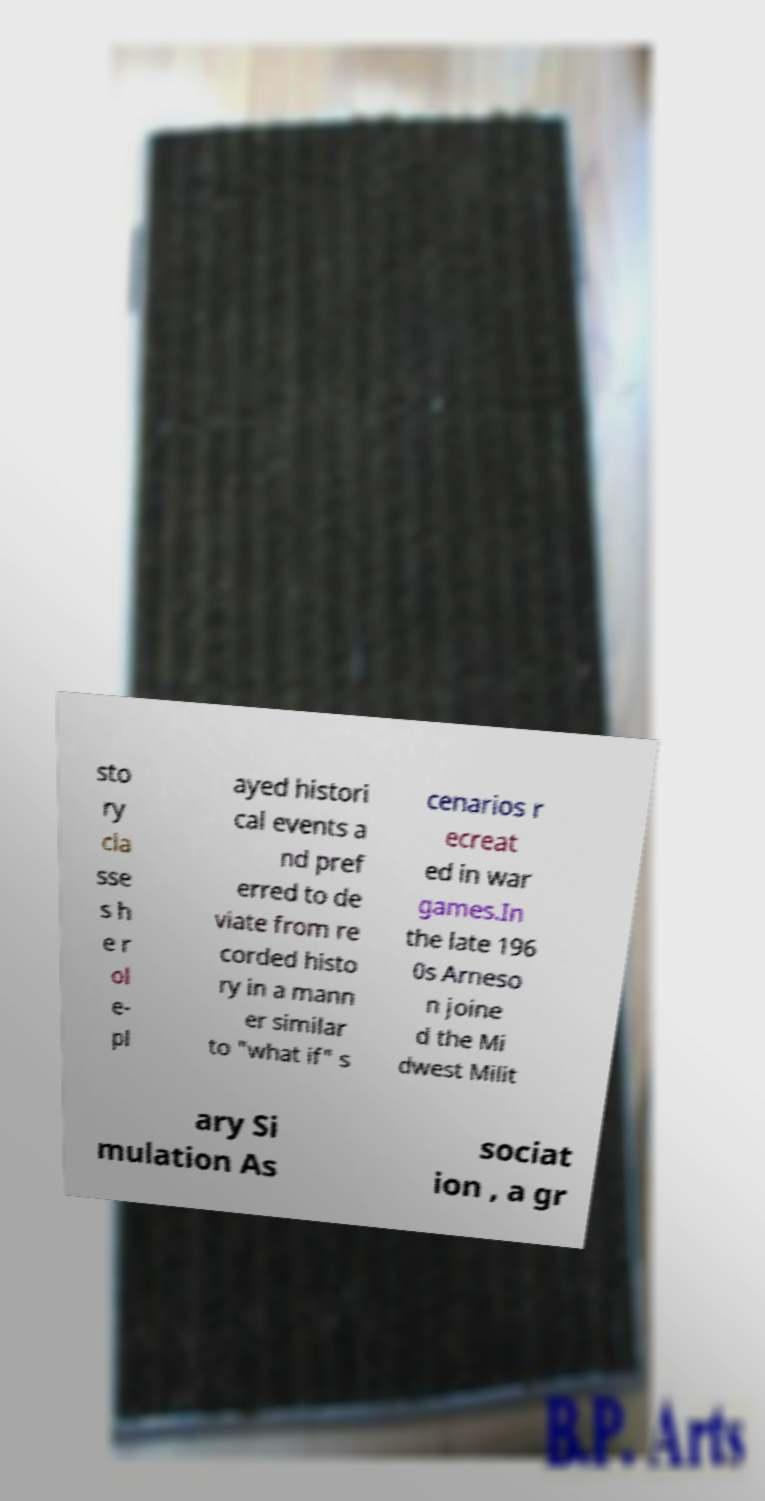I need the written content from this picture converted into text. Can you do that? sto ry cla sse s h e r ol e- pl ayed histori cal events a nd pref erred to de viate from re corded histo ry in a mann er similar to "what if" s cenarios r ecreat ed in war games.In the late 196 0s Arneso n joine d the Mi dwest Milit ary Si mulation As sociat ion , a gr 